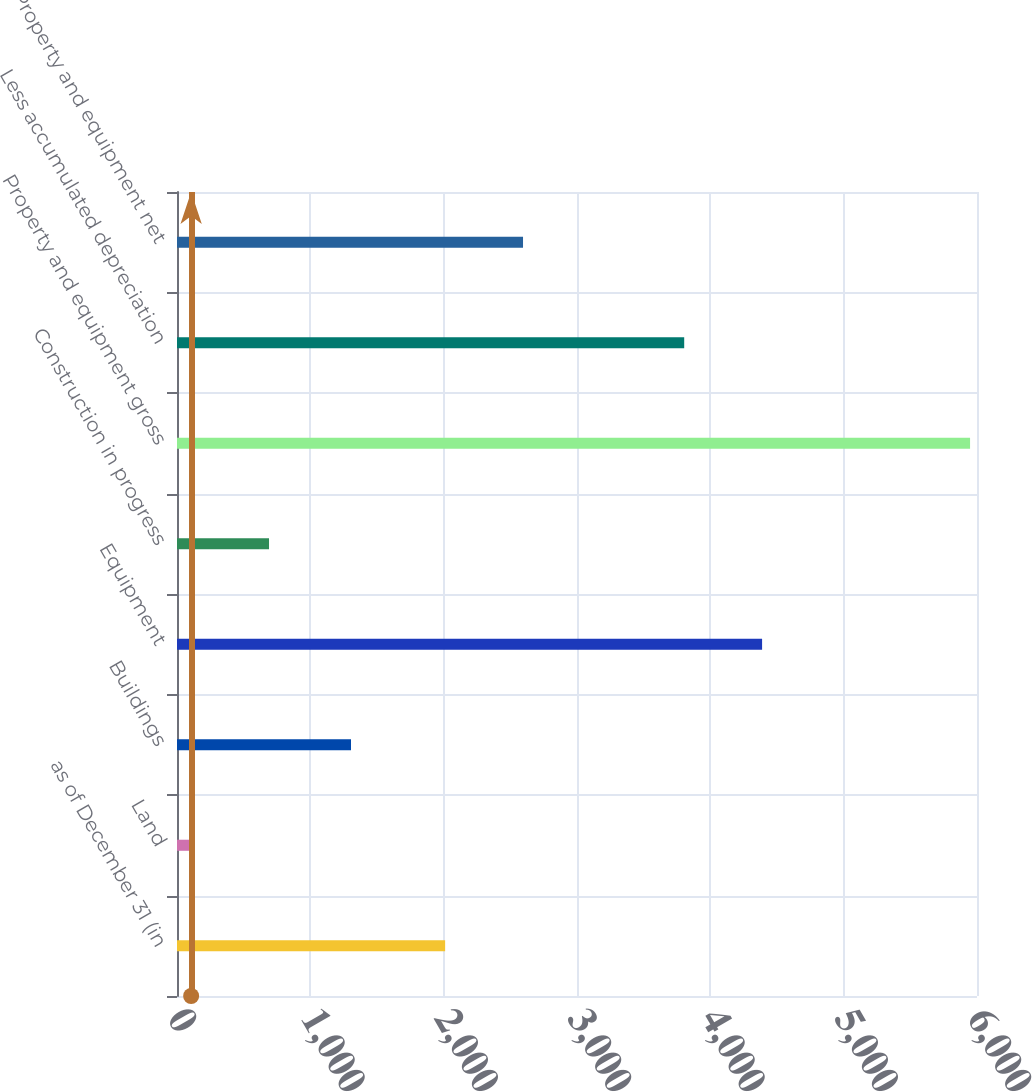<chart> <loc_0><loc_0><loc_500><loc_500><bar_chart><fcel>as of December 31 (in<fcel>Land<fcel>Buildings<fcel>Equipment<fcel>Construction in progress<fcel>Property and equipment gross<fcel>Less accumulated depreciation<fcel>Property and equipment net<nl><fcel>2011<fcel>106<fcel>1305<fcel>4388.2<fcel>690.2<fcel>5948<fcel>3804<fcel>2595.2<nl></chart> 